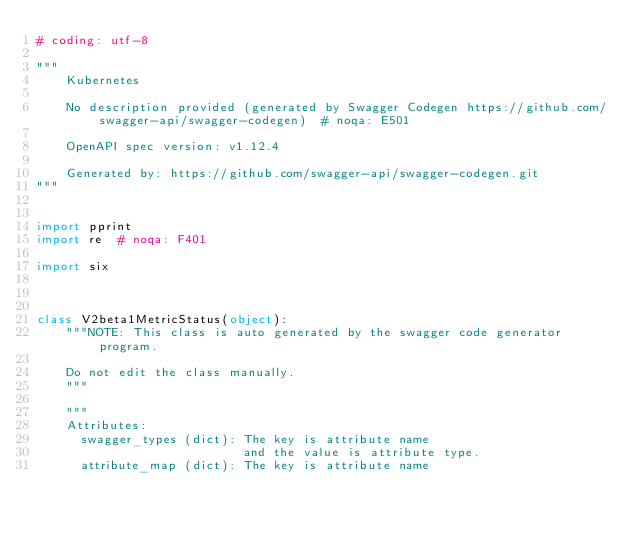<code> <loc_0><loc_0><loc_500><loc_500><_Python_># coding: utf-8

"""
    Kubernetes

    No description provided (generated by Swagger Codegen https://github.com/swagger-api/swagger-codegen)  # noqa: E501

    OpenAPI spec version: v1.12.4
    
    Generated by: https://github.com/swagger-api/swagger-codegen.git
"""


import pprint
import re  # noqa: F401

import six



class V2beta1MetricStatus(object):
    """NOTE: This class is auto generated by the swagger code generator program.

    Do not edit the class manually.
    """

    """
    Attributes:
      swagger_types (dict): The key is attribute name
                            and the value is attribute type.
      attribute_map (dict): The key is attribute name</code> 